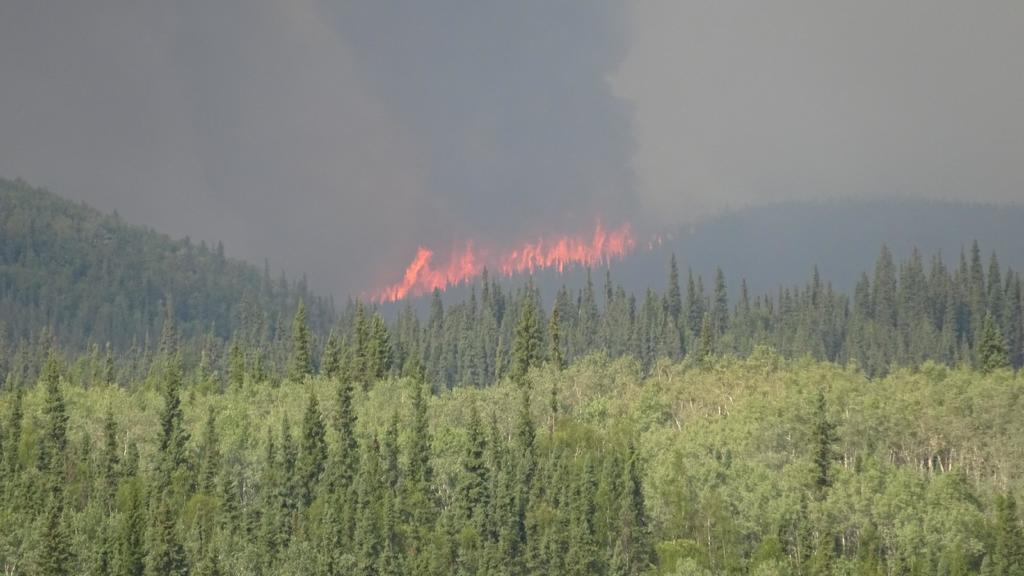What type of vegetation is visible in the front of the image? There are trees in the front of the image. What can be seen in the background of the image? There is smoke, fire, and the sky visible in the background of the image. What type of brake is being used to stop the trees in the image? There is no brake present in the image, as trees are stationary vegetation. Can you see a lamp illuminating the fire in the background of the image? There is no lamp present in the image; only smoke, fire, and the sky are visible in the background. 